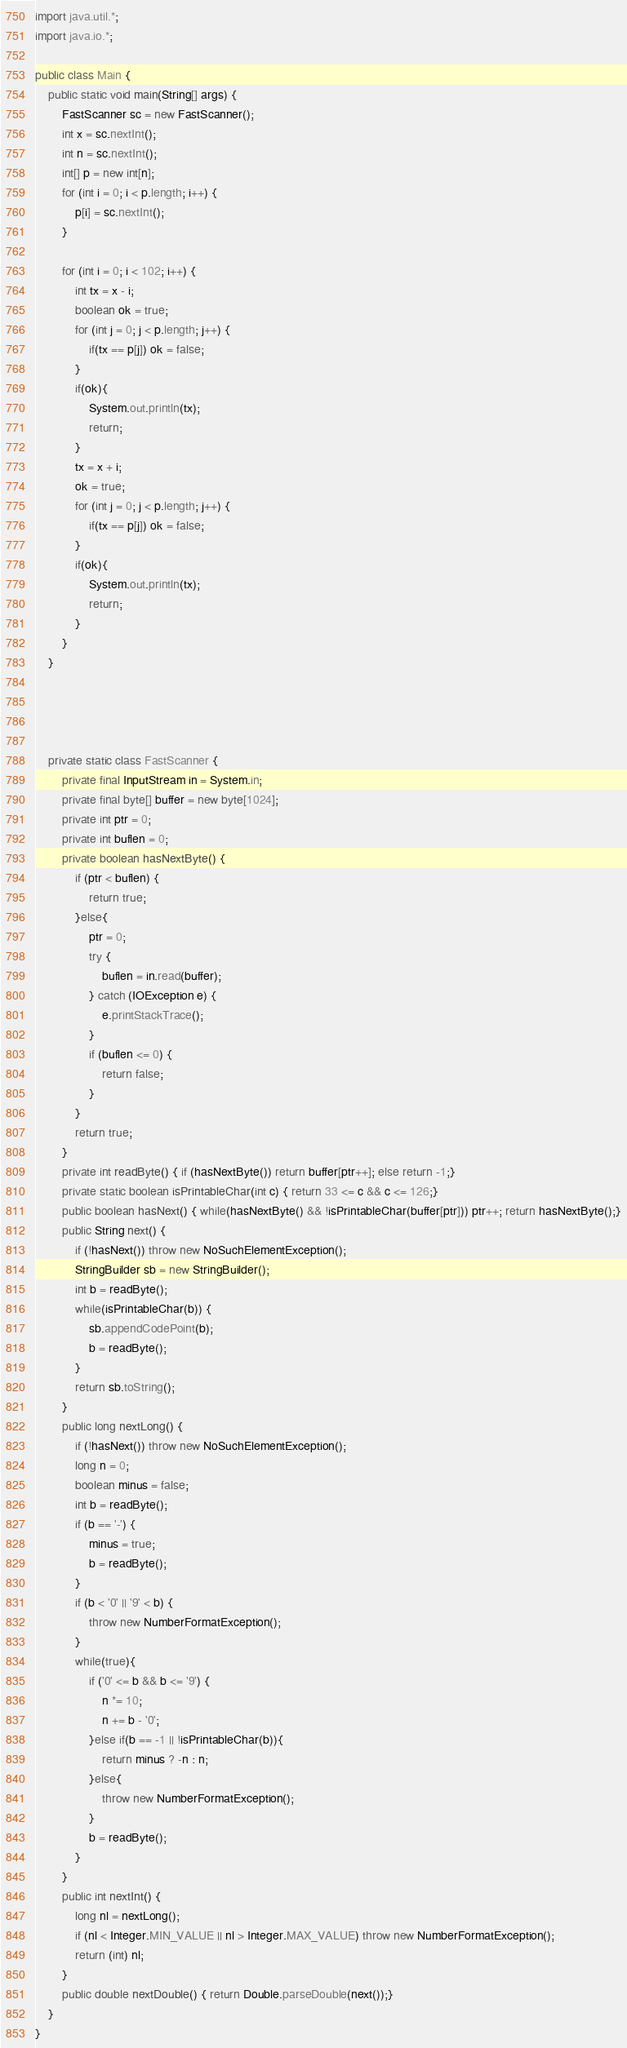<code> <loc_0><loc_0><loc_500><loc_500><_Java_>import java.util.*;
import java.io.*;

public class Main {
    public static void main(String[] args) {
        FastScanner sc = new FastScanner();
        int x = sc.nextInt();
        int n = sc.nextInt();
        int[] p = new int[n];
        for (int i = 0; i < p.length; i++) {
            p[i] = sc.nextInt();
        }

        for (int i = 0; i < 102; i++) {
            int tx = x - i;
            boolean ok = true;
            for (int j = 0; j < p.length; j++) {
                if(tx == p[j]) ok = false;
            }
            if(ok){
                System.out.println(tx);
                return;
            }
            tx = x + i;
            ok = true;
            for (int j = 0; j < p.length; j++) {
                if(tx == p[j]) ok = false;
            }
            if(ok){
                System.out.println(tx);
                return;
            }
        }
    }




    private static class FastScanner {
        private final InputStream in = System.in;
        private final byte[] buffer = new byte[1024];
        private int ptr = 0;
        private int buflen = 0;
        private boolean hasNextByte() {
            if (ptr < buflen) {
                return true;
            }else{
                ptr = 0;
                try {
                    buflen = in.read(buffer);
                } catch (IOException e) {
                    e.printStackTrace();
                }
                if (buflen <= 0) {
                    return false;
                }
            }
            return true;
        }
        private int readByte() { if (hasNextByte()) return buffer[ptr++]; else return -1;}
        private static boolean isPrintableChar(int c) { return 33 <= c && c <= 126;}
        public boolean hasNext() { while(hasNextByte() && !isPrintableChar(buffer[ptr])) ptr++; return hasNextByte();}
        public String next() {
            if (!hasNext()) throw new NoSuchElementException();
            StringBuilder sb = new StringBuilder();
            int b = readByte();
            while(isPrintableChar(b)) {
                sb.appendCodePoint(b);
                b = readByte();
            }
            return sb.toString();
        }
        public long nextLong() {
            if (!hasNext()) throw new NoSuchElementException();
            long n = 0;
            boolean minus = false;
            int b = readByte();
            if (b == '-') {
                minus = true;
                b = readByte();
            }
            if (b < '0' || '9' < b) {
                throw new NumberFormatException();
            }
            while(true){
                if ('0' <= b && b <= '9') {
                    n *= 10;
                    n += b - '0';
                }else if(b == -1 || !isPrintableChar(b)){
                    return minus ? -n : n;
                }else{
                    throw new NumberFormatException();
                }
                b = readByte();
            }
        }
        public int nextInt() {
            long nl = nextLong();
            if (nl < Integer.MIN_VALUE || nl > Integer.MAX_VALUE) throw new NumberFormatException();
            return (int) nl;
        }
        public double nextDouble() { return Double.parseDouble(next());}
    }
}
</code> 